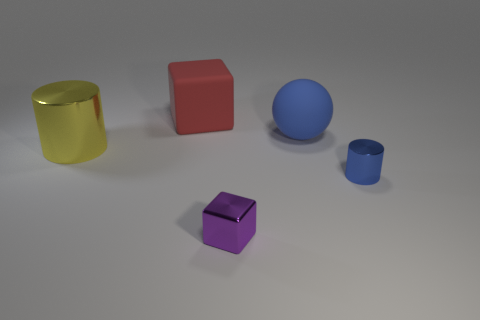Add 1 large shiny cylinders. How many objects exist? 6 Subtract all cylinders. How many objects are left? 3 Subtract 1 yellow cylinders. How many objects are left? 4 Subtract all large matte cubes. Subtract all small metal cylinders. How many objects are left? 3 Add 1 big spheres. How many big spheres are left? 2 Add 2 gray spheres. How many gray spheres exist? 2 